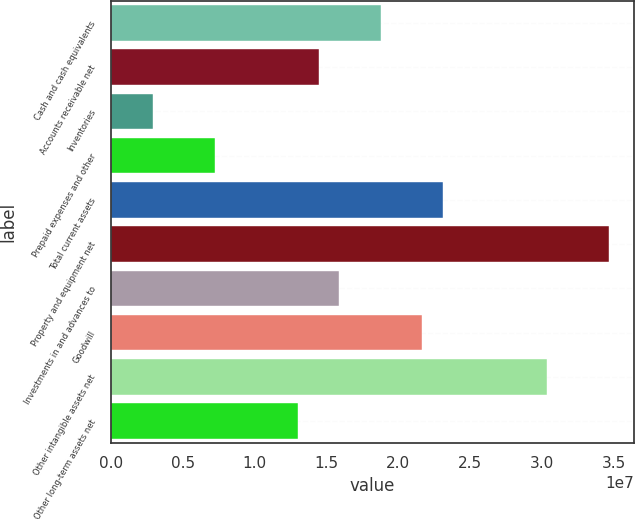Convert chart to OTSL. <chart><loc_0><loc_0><loc_500><loc_500><bar_chart><fcel>Cash and cash equivalents<fcel>Accounts receivable net<fcel>Inventories<fcel>Prepaid expenses and other<fcel>Total current assets<fcel>Property and equipment net<fcel>Investments in and advances to<fcel>Goodwill<fcel>Other intangible assets net<fcel>Other long-term assets net<nl><fcel>1.87725e+07<fcel>1.44415e+07<fcel>2.89224e+06<fcel>7.22323e+06<fcel>2.31035e+07<fcel>3.46528e+07<fcel>1.58852e+07<fcel>2.16599e+07<fcel>3.03218e+07<fcel>1.29979e+07<nl></chart> 